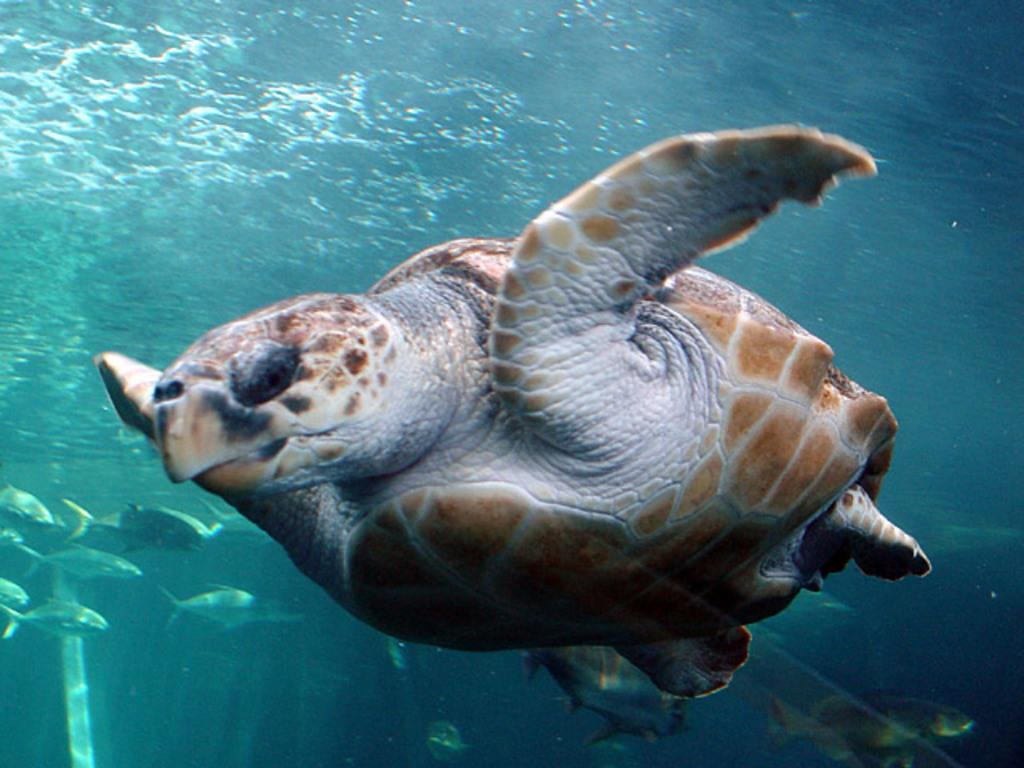What type of animal can be seen in the image? There is a turtle in the image. What other creatures are present in the image? There are fishes in the image. Where are the turtle and fishes located? The turtle and fishes are underwater. What type of leaf is being used as a decoration in the image? There is no leaf present in the image; it features a turtle and fishes underwater. 